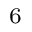<formula> <loc_0><loc_0><loc_500><loc_500>_ { 6 }</formula> 